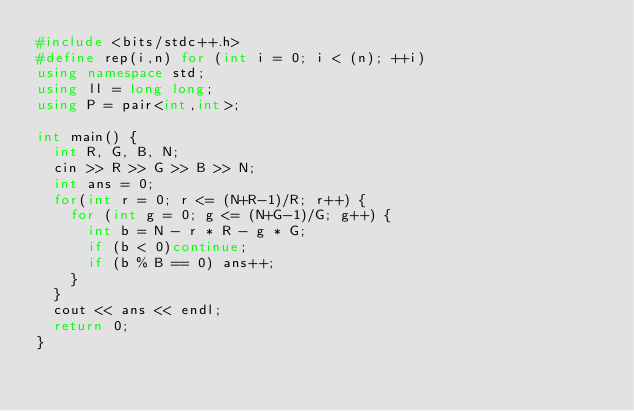Convert code to text. <code><loc_0><loc_0><loc_500><loc_500><_C++_>#include <bits/stdc++.h>
#define rep(i,n) for (int i = 0; i < (n); ++i)
using namespace std;
using ll = long long;
using P = pair<int,int>;

int main() {
  int R, G, B, N;
  cin >> R >> G >> B >> N;
  int ans = 0;
  for(int r = 0; r <= (N+R-1)/R; r++) {
    for (int g = 0; g <= (N+G-1)/G; g++) {
      int b = N - r * R - g * G;
      if (b < 0)continue;
      if (b % B == 0) ans++;
    }
  }
  cout << ans << endl;
  return 0;
}
</code> 